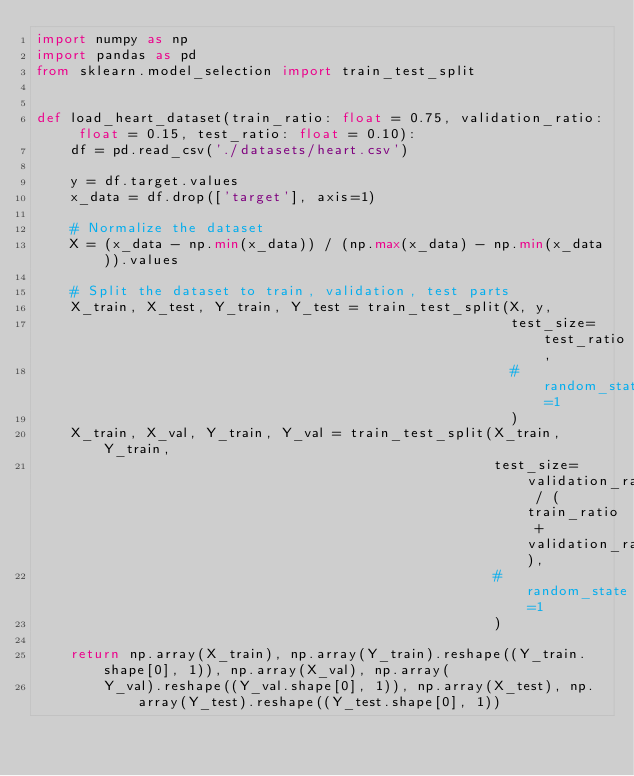Convert code to text. <code><loc_0><loc_0><loc_500><loc_500><_Python_>import numpy as np
import pandas as pd
from sklearn.model_selection import train_test_split


def load_heart_dataset(train_ratio: float = 0.75, validation_ratio: float = 0.15, test_ratio: float = 0.10):
    df = pd.read_csv('./datasets/heart.csv')

    y = df.target.values
    x_data = df.drop(['target'], axis=1)

    # Normalize the dataset
    X = (x_data - np.min(x_data)) / (np.max(x_data) - np.min(x_data)).values

    # Split the dataset to train, validation, test parts
    X_train, X_test, Y_train, Y_test = train_test_split(X, y,
                                                        test_size=test_ratio,
                                                        # random_state=1
                                                        )
    X_train, X_val, Y_train, Y_val = train_test_split(X_train, Y_train,
                                                      test_size=validation_ratio / (train_ratio + validation_ratio),
                                                      # random_state=1
                                                      )

    return np.array(X_train), np.array(Y_train).reshape((Y_train.shape[0], 1)), np.array(X_val), np.array(
        Y_val).reshape((Y_val.shape[0], 1)), np.array(X_test), np.array(Y_test).reshape((Y_test.shape[0], 1))
</code> 